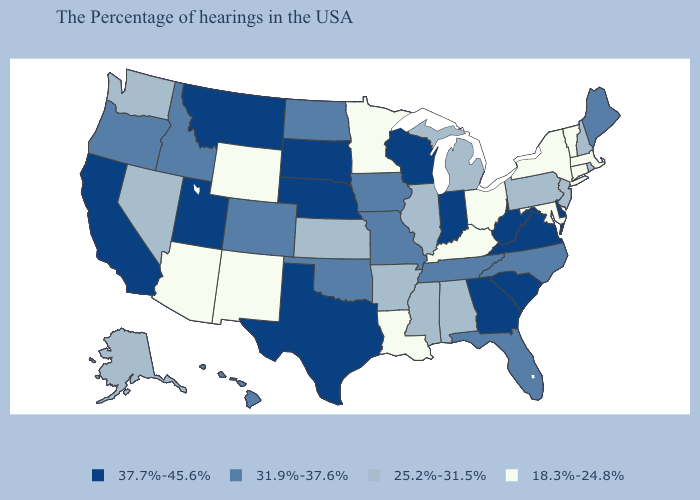Among the states that border Vermont , does New York have the highest value?
Write a very short answer. No. Does New Mexico have a lower value than Tennessee?
Keep it brief. Yes. Among the states that border New Jersey , which have the highest value?
Be succinct. Delaware. Among the states that border Iowa , does Minnesota have the highest value?
Concise answer only. No. Among the states that border Florida , which have the lowest value?
Quick response, please. Alabama. How many symbols are there in the legend?
Short answer required. 4. Name the states that have a value in the range 37.7%-45.6%?
Short answer required. Delaware, Virginia, South Carolina, West Virginia, Georgia, Indiana, Wisconsin, Nebraska, Texas, South Dakota, Utah, Montana, California. Does the map have missing data?
Quick response, please. No. Name the states that have a value in the range 37.7%-45.6%?
Short answer required. Delaware, Virginia, South Carolina, West Virginia, Georgia, Indiana, Wisconsin, Nebraska, Texas, South Dakota, Utah, Montana, California. Does Virginia have the highest value in the USA?
Give a very brief answer. Yes. What is the value of Arizona?
Answer briefly. 18.3%-24.8%. Name the states that have a value in the range 31.9%-37.6%?
Answer briefly. Maine, North Carolina, Florida, Tennessee, Missouri, Iowa, Oklahoma, North Dakota, Colorado, Idaho, Oregon, Hawaii. What is the value of Indiana?
Answer briefly. 37.7%-45.6%. Does Utah have the lowest value in the West?
Keep it brief. No. Among the states that border South Dakota , which have the highest value?
Quick response, please. Nebraska, Montana. 